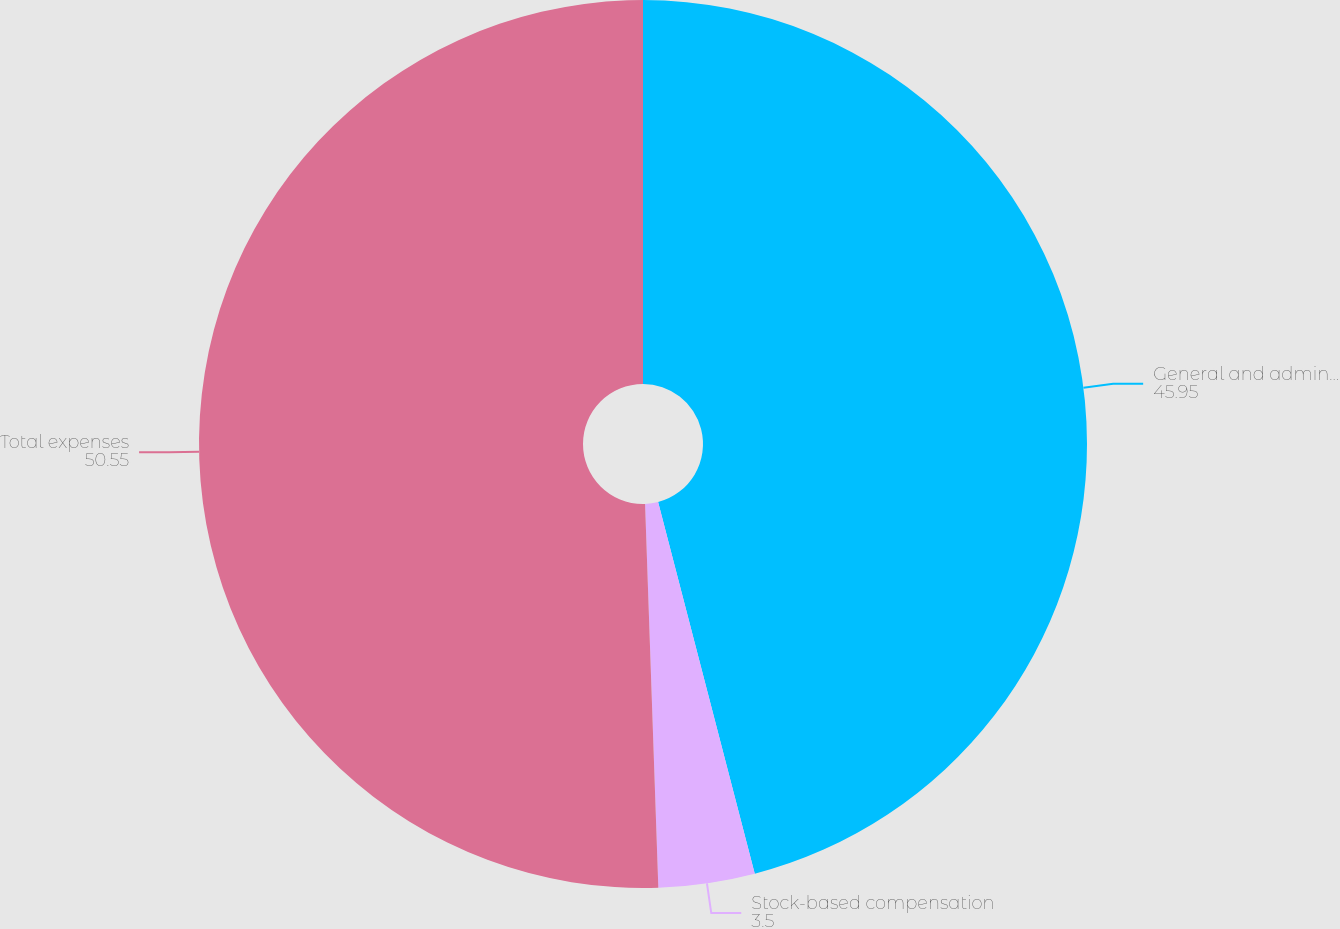Convert chart to OTSL. <chart><loc_0><loc_0><loc_500><loc_500><pie_chart><fcel>General and administrative^(1)<fcel>Stock-based compensation<fcel>Total expenses<nl><fcel>45.95%<fcel>3.5%<fcel>50.55%<nl></chart> 